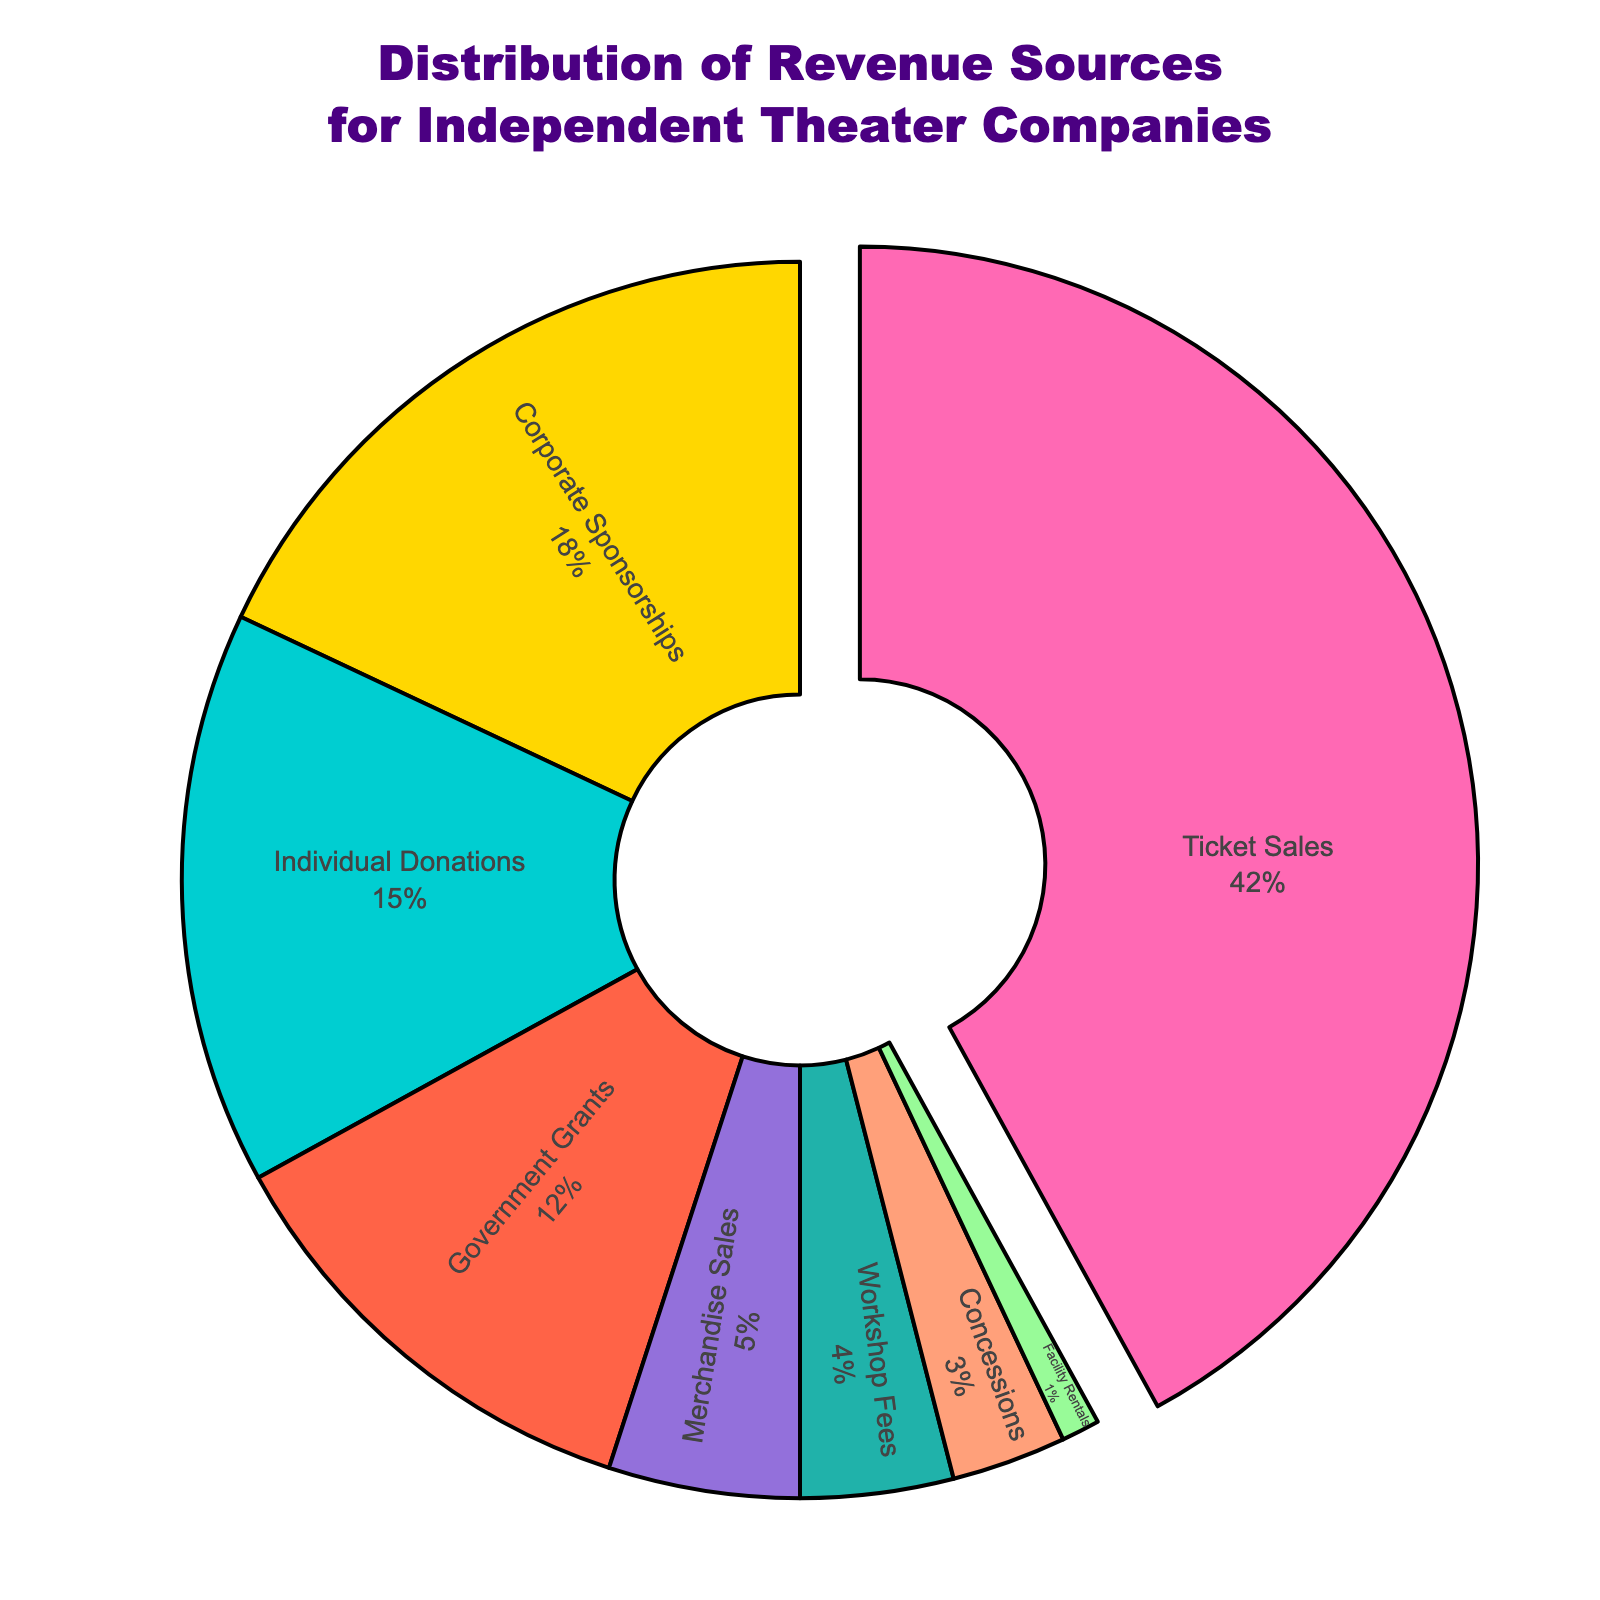What is the largest source of revenue for independent theater companies? The largest slice of the pie chart is Ticket Sales with 42%, making it the biggest source of revenue.
Answer: Ticket Sales How much more percentage does Ticket Sales contribute compared to Corporate Sponsorships? Ticket Sales contributes 42%, while Corporate Sponsorships contribute 18%. The difference is 42 - 18 = 24%.
Answer: 24% Which revenue source has the smallest contribution and what percentage is it? The smallest slice of the pie chart is Facility Rentals which shows 1%.
Answer: Facility Rentals, 1% If Individual Donations and Government Grants were combined, what would their total percentage be? Individual Donations contribute 15% and Government Grants contribute 12%. Combined, they contribute 15 + 12 = 27%.
Answer: 27% Are the combined revenues from Merchandise Sales, Workshop Fees, and Concessions greater than the revenue from Government Grants? Merchandise Sales contribute 5%, Workshop Fees contribute 4%, and Concessions contribute 3%. Their total is 5 + 4 + 3 = 12%. This is equal to the Government Grants contribution of 12%.
Answer: No Which section of the pie chart is represented by the light blue color? The light blue color represents Merchandise Sales which is marked at 5%.
Answer: Merchandise Sales Is the contribution of Individual Donations greater than the sum of Workshop Fees and Facility Rentals? Individual Donations contribute 15%, Workshop Fees contribute 4%, and Facility Rentals contribute 1%. The sum of the latter two is 4 + 1 = 5%, which is less than 15%.
Answer: Yes What percentage of the pie chart is pulled out, and which revenue source does it represent? The slice pulled out represents Ticket Sales, which is 42%.
Answer: 42% Combining Ticket Sales and Corporate Sponsorships, what is their total percentage of contribution? Ticket Sales contribute 42% and Corporate Sponsorships contribute 18%. Combined, they contribute 42 + 18 = 60%.
Answer: 60% Is there any revenue source contributing less than 5%? If yes, name them. Yes, there are. They are Workshop Fees (4%), Concessions (3%), and Facility Rentals (1%).
Answer: Yes, Workshop Fees, Concessions, Facility Rentals 